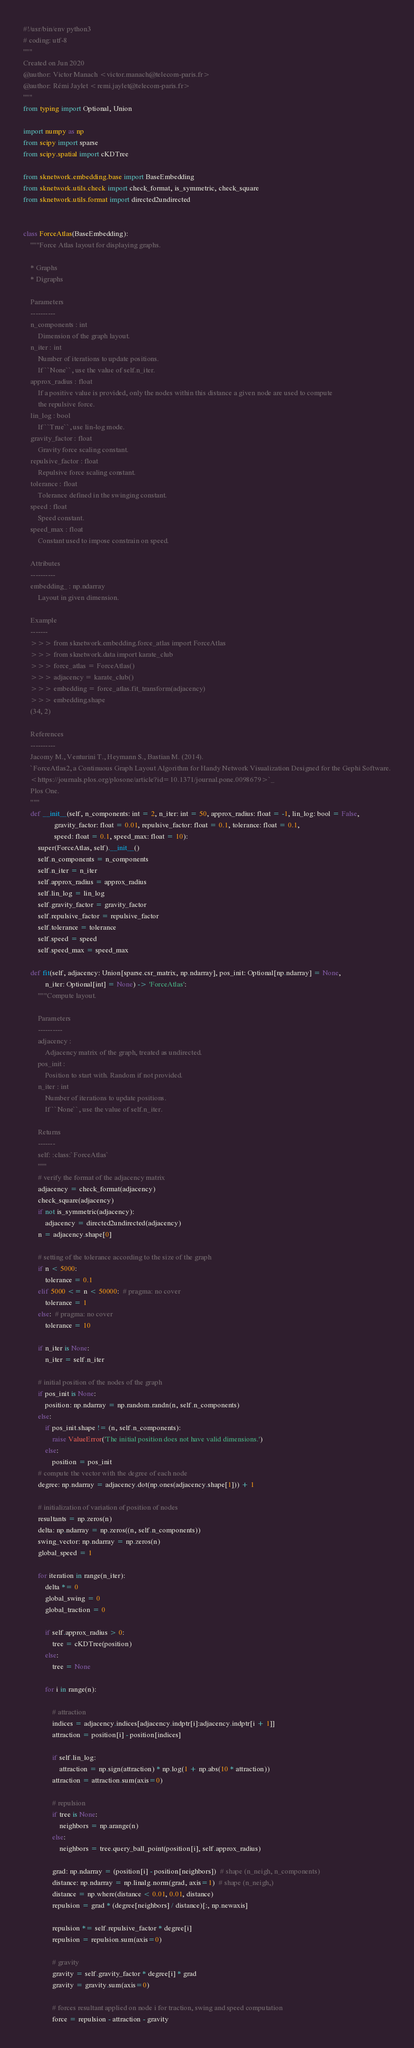Convert code to text. <code><loc_0><loc_0><loc_500><loc_500><_Python_>#!/usr/bin/env python3
# coding: utf-8
"""
Created on Jun 2020
@author: Victor Manach <victor.manach@telecom-paris.fr>
@author: Rémi Jaylet <remi.jaylet@telecom-paris.fr>
"""
from typing import Optional, Union

import numpy as np
from scipy import sparse
from scipy.spatial import cKDTree

from sknetwork.embedding.base import BaseEmbedding
from sknetwork.utils.check import check_format, is_symmetric, check_square
from sknetwork.utils.format import directed2undirected


class ForceAtlas(BaseEmbedding):
    """Force Atlas layout for displaying graphs.

    * Graphs
    * Digraphs

    Parameters
    ----------
    n_components : int
        Dimension of the graph layout.
    n_iter : int
        Number of iterations to update positions.
        If ``None``, use the value of self.n_iter.
    approx_radius : float
        If a positive value is provided, only the nodes within this distance a given node are used to compute
        the repulsive force.
    lin_log : bool
        If ``True``, use lin-log mode.
    gravity_factor : float
        Gravity force scaling constant.
    repulsive_factor : float
        Repulsive force scaling constant.
    tolerance : float
        Tolerance defined in the swinging constant.
    speed : float
        Speed constant.
    speed_max : float
        Constant used to impose constrain on speed.

    Attributes
    ----------
    embedding_ : np.ndarray
        Layout in given dimension.

    Example
    -------
    >>> from sknetwork.embedding.force_atlas import ForceAtlas
    >>> from sknetwork.data import karate_club
    >>> force_atlas = ForceAtlas()
    >>> adjacency = karate_club()
    >>> embedding = force_atlas.fit_transform(adjacency)
    >>> embedding.shape
    (34, 2)

    References
    ----------
    Jacomy M., Venturini T., Heymann S., Bastian M. (2014).
    `ForceAtlas2, a Continuous Graph Layout Algorithm for Handy Network Visualization Designed for the Gephi Software.
    <https://journals.plos.org/plosone/article?id=10.1371/journal.pone.0098679>`_
    Plos One.
    """
    def __init__(self, n_components: int = 2, n_iter: int = 50, approx_radius: float = -1, lin_log: bool = False,
                 gravity_factor: float = 0.01, repulsive_factor: float = 0.1, tolerance: float = 0.1,
                 speed: float = 0.1, speed_max: float = 10):
        super(ForceAtlas, self).__init__()
        self.n_components = n_components
        self.n_iter = n_iter
        self.approx_radius = approx_radius
        self.lin_log = lin_log
        self.gravity_factor = gravity_factor
        self.repulsive_factor = repulsive_factor
        self.tolerance = tolerance
        self.speed = speed
        self.speed_max = speed_max

    def fit(self, adjacency: Union[sparse.csr_matrix, np.ndarray], pos_init: Optional[np.ndarray] = None,
            n_iter: Optional[int] = None) -> 'ForceAtlas':
        """Compute layout.

        Parameters
        ----------
        adjacency :
            Adjacency matrix of the graph, treated as undirected.
        pos_init :
            Position to start with. Random if not provided.
        n_iter : int
            Number of iterations to update positions.
            If ``None``, use the value of self.n_iter.

        Returns
        -------
        self: :class:`ForceAtlas`
        """
        # verify the format of the adjacency matrix
        adjacency = check_format(adjacency)
        check_square(adjacency)
        if not is_symmetric(adjacency):
            adjacency = directed2undirected(adjacency)
        n = adjacency.shape[0]

        # setting of the tolerance according to the size of the graph
        if n < 5000:
            tolerance = 0.1
        elif 5000 <= n < 50000:  # pragma: no cover
            tolerance = 1
        else:  # pragma: no cover
            tolerance = 10

        if n_iter is None:
            n_iter = self.n_iter

        # initial position of the nodes of the graph
        if pos_init is None:
            position: np.ndarray = np.random.randn(n, self.n_components)
        else:
            if pos_init.shape != (n, self.n_components):
                raise ValueError('The initial position does not have valid dimensions.')
            else:
                position = pos_init
        # compute the vector with the degree of each node
        degree: np.ndarray = adjacency.dot(np.ones(adjacency.shape[1])) + 1

        # initialization of variation of position of nodes
        resultants = np.zeros(n)
        delta: np.ndarray = np.zeros((n, self.n_components))
        swing_vector: np.ndarray = np.zeros(n)
        global_speed = 1

        for iteration in range(n_iter):
            delta *= 0
            global_swing = 0
            global_traction = 0

            if self.approx_radius > 0:
                tree = cKDTree(position)
            else:
                tree = None

            for i in range(n):

                # attraction
                indices = adjacency.indices[adjacency.indptr[i]:adjacency.indptr[i + 1]]
                attraction = position[i] - position[indices]

                if self.lin_log:
                    attraction = np.sign(attraction) * np.log(1 + np.abs(10 * attraction))
                attraction = attraction.sum(axis=0)

                # repulsion
                if tree is None:
                    neighbors = np.arange(n)
                else:
                    neighbors = tree.query_ball_point(position[i], self.approx_radius)

                grad: np.ndarray = (position[i] - position[neighbors])  # shape (n_neigh, n_components)
                distance: np.ndarray = np.linalg.norm(grad, axis=1)  # shape (n_neigh,)
                distance = np.where(distance < 0.01, 0.01, distance)
                repulsion = grad * (degree[neighbors] / distance)[:, np.newaxis]

                repulsion *= self.repulsive_factor * degree[i]
                repulsion = repulsion.sum(axis=0)

                # gravity
                gravity = self.gravity_factor * degree[i] * grad
                gravity = gravity.sum(axis=0)

                # forces resultant applied on node i for traction, swing and speed computation
                force = repulsion - attraction - gravity</code> 